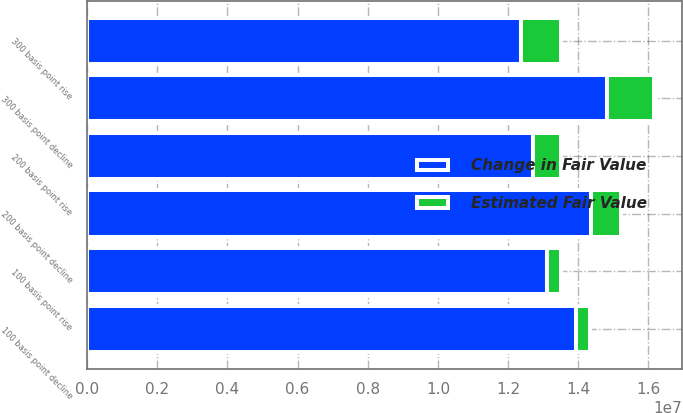<chart> <loc_0><loc_0><loc_500><loc_500><stacked_bar_chart><ecel><fcel>300 basis point rise<fcel>200 basis point rise<fcel>100 basis point rise<fcel>100 basis point decline<fcel>200 basis point decline<fcel>300 basis point decline<nl><fcel>Change in Fair Value<fcel>1.23605e+07<fcel>1.27199e+07<fcel>1.31002e+07<fcel>1.39252e+07<fcel>1.43642e+07<fcel>1.48245e+07<nl><fcel>Estimated Fair Value<fcel>1.14172e+06<fcel>782367<fcel>401988<fcel>422989<fcel>861940<fcel>1.32232e+06<nl></chart> 